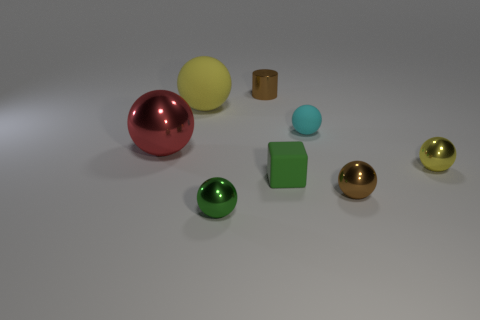Subtract all green spheres. How many spheres are left? 5 Subtract all tiny cyan balls. How many balls are left? 5 Subtract all purple balls. Subtract all purple cylinders. How many balls are left? 6 Add 2 red rubber cylinders. How many objects exist? 10 Subtract all cylinders. How many objects are left? 7 Add 6 large cylinders. How many large cylinders exist? 6 Subtract 1 cyan spheres. How many objects are left? 7 Subtract all cyan balls. Subtract all large cyan things. How many objects are left? 7 Add 4 small yellow spheres. How many small yellow spheres are left? 5 